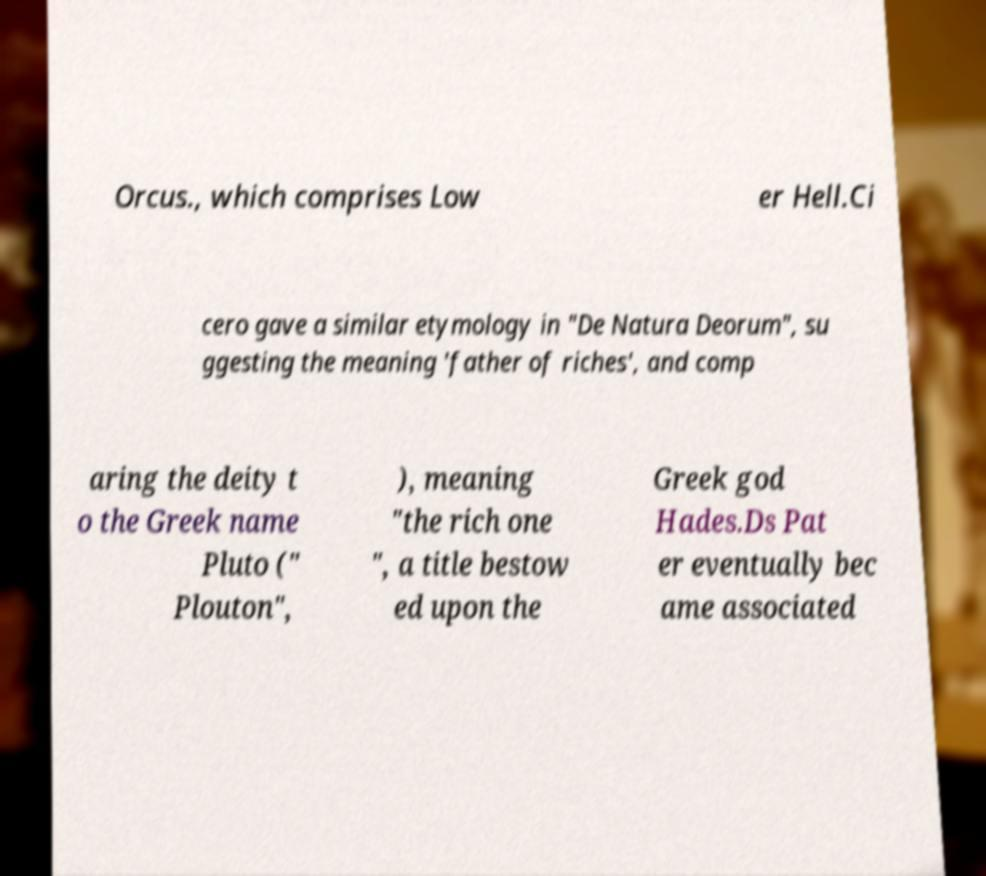For documentation purposes, I need the text within this image transcribed. Could you provide that? Orcus., which comprises Low er Hell.Ci cero gave a similar etymology in "De Natura Deorum", su ggesting the meaning 'father of riches', and comp aring the deity t o the Greek name Pluto (" Plouton", ), meaning "the rich one ", a title bestow ed upon the Greek god Hades.Ds Pat er eventually bec ame associated 